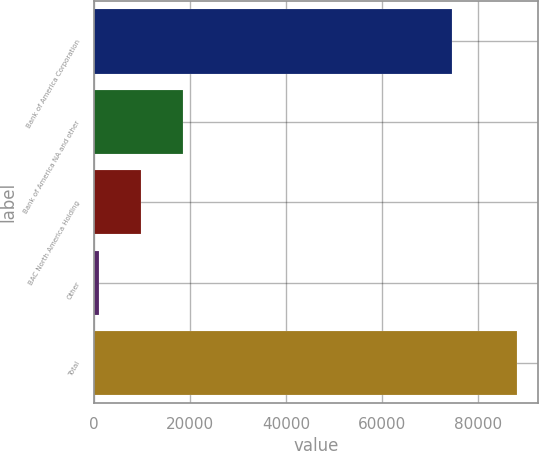Convert chart. <chart><loc_0><loc_0><loc_500><loc_500><bar_chart><fcel>Bank of America Corporation<fcel>Bank of America NA and other<fcel>BAC North America Holding<fcel>Other<fcel>Total<nl><fcel>74722<fcel>18495.4<fcel>9774.2<fcel>1053<fcel>88265<nl></chart> 